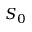Convert formula to latex. <formula><loc_0><loc_0><loc_500><loc_500>S _ { 0 }</formula> 